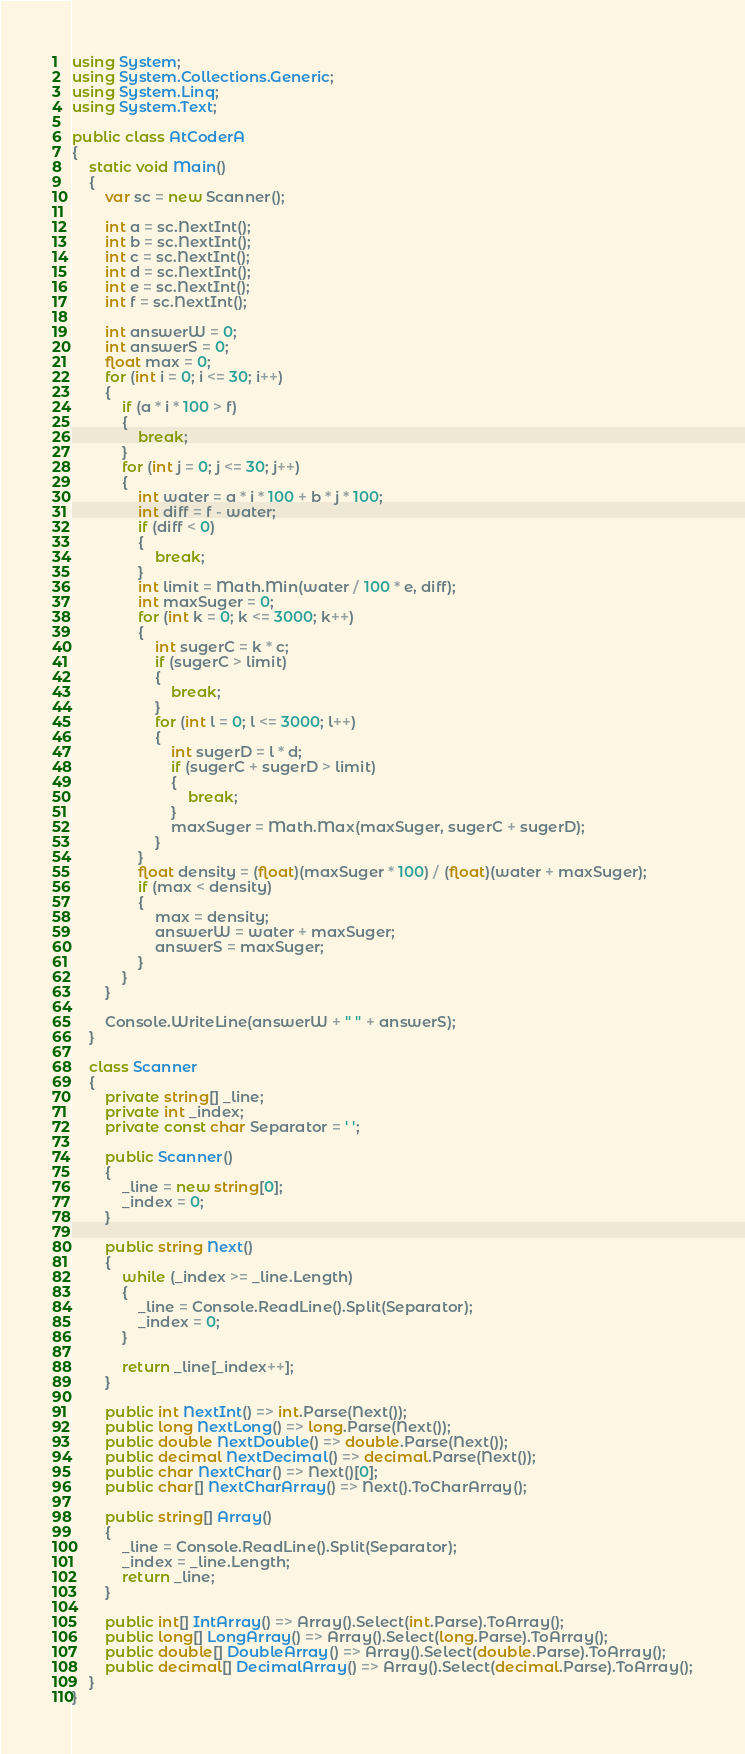<code> <loc_0><loc_0><loc_500><loc_500><_C#_>using System;
using System.Collections.Generic;
using System.Linq;
using System.Text;

public class AtCoderA
{
    static void Main()
    {
        var sc = new Scanner();

        int a = sc.NextInt();
        int b = sc.NextInt();
        int c = sc.NextInt();
        int d = sc.NextInt();
        int e = sc.NextInt();
        int f = sc.NextInt();

        int answerW = 0;
        int answerS = 0;
        float max = 0;
        for (int i = 0; i <= 30; i++)
        {
            if (a * i * 100 > f)
            {
                break;
            }
            for (int j = 0; j <= 30; j++)
            {
                int water = a * i * 100 + b * j * 100;
                int diff = f - water;
                if (diff < 0)
                {
                    break;
                }
                int limit = Math.Min(water / 100 * e, diff);
                int maxSuger = 0;
                for (int k = 0; k <= 3000; k++)
                {
                    int sugerC = k * c;
                    if (sugerC > limit)
                    {
                        break;
                    }
                    for (int l = 0; l <= 3000; l++)
                    {
                        int sugerD = l * d;
                        if (sugerC + sugerD > limit)
                        {
                            break;
                        }
                        maxSuger = Math.Max(maxSuger, sugerC + sugerD);
                    }
                }
                float density = (float)(maxSuger * 100) / (float)(water + maxSuger);
                if (max < density)
                {
                    max = density;
                    answerW = water + maxSuger;
                    answerS = maxSuger;
                }
            }
        }

        Console.WriteLine(answerW + " " + answerS);
    }

    class Scanner
    {
        private string[] _line;
        private int _index;
        private const char Separator = ' ';

        public Scanner()
        {
            _line = new string[0];
            _index = 0;
        }

        public string Next()
        {
            while (_index >= _line.Length)
            {
                _line = Console.ReadLine().Split(Separator);
                _index = 0;
            }

            return _line[_index++];
        }

        public int NextInt() => int.Parse(Next());
        public long NextLong() => long.Parse(Next());
        public double NextDouble() => double.Parse(Next());
        public decimal NextDecimal() => decimal.Parse(Next());
        public char NextChar() => Next()[0];
        public char[] NextCharArray() => Next().ToCharArray();

        public string[] Array()
        {
            _line = Console.ReadLine().Split(Separator);
            _index = _line.Length;
            return _line;
        }

        public int[] IntArray() => Array().Select(int.Parse).ToArray();
        public long[] LongArray() => Array().Select(long.Parse).ToArray();
        public double[] DoubleArray() => Array().Select(double.Parse).ToArray();
        public decimal[] DecimalArray() => Array().Select(decimal.Parse).ToArray();
    }
}</code> 